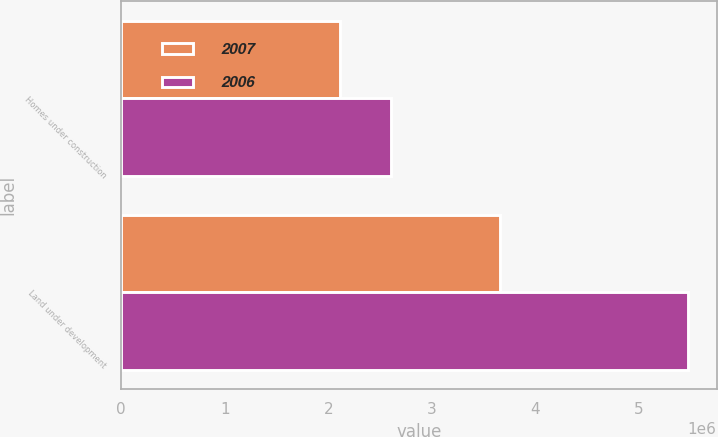Convert chart to OTSL. <chart><loc_0><loc_0><loc_500><loc_500><stacked_bar_chart><ecel><fcel>Homes under construction<fcel>Land under development<nl><fcel>2007<fcel>2.1151e+06<fcel>3.65662e+06<nl><fcel>2006<fcel>2.60661e+06<fcel>5.47824e+06<nl></chart> 